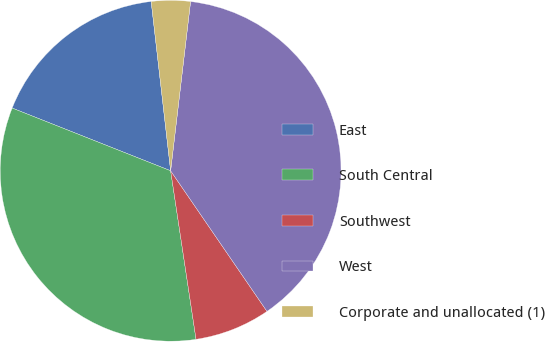<chart> <loc_0><loc_0><loc_500><loc_500><pie_chart><fcel>East<fcel>South Central<fcel>Southwest<fcel>West<fcel>Corporate and unallocated (1)<nl><fcel>17.18%<fcel>33.38%<fcel>7.18%<fcel>38.57%<fcel>3.69%<nl></chart> 